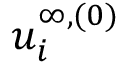<formula> <loc_0><loc_0><loc_500><loc_500>u _ { i } ^ { \infty , ( 0 ) }</formula> 